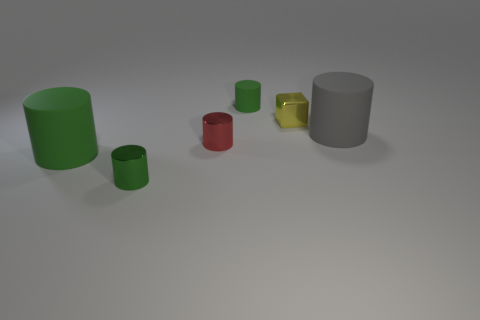What is the shape of the big object that is the same color as the tiny rubber thing?
Provide a short and direct response. Cylinder. There is a matte object that is right of the tiny green object that is behind the tiny green cylinder in front of the gray cylinder; what size is it?
Provide a short and direct response. Large. How many other objects are the same shape as the yellow thing?
Offer a terse response. 0. What is the color of the metallic object that is left of the yellow object and behind the green shiny cylinder?
Provide a short and direct response. Red. There is a rubber cylinder that is to the left of the small green rubber cylinder; is it the same color as the small rubber cylinder?
Ensure brevity in your answer.  Yes. How many cylinders are red metal objects or small green metal things?
Make the answer very short. 2. There is a large rubber thing that is behind the red object; what is its shape?
Your answer should be very brief. Cylinder. What color is the big thing that is to the left of the large gray matte cylinder that is on the right side of the large cylinder on the left side of the small matte cylinder?
Provide a succinct answer. Green. Is the tiny red cylinder made of the same material as the tiny yellow cube?
Ensure brevity in your answer.  Yes. What number of yellow objects are matte things or shiny cylinders?
Your answer should be compact. 0. 